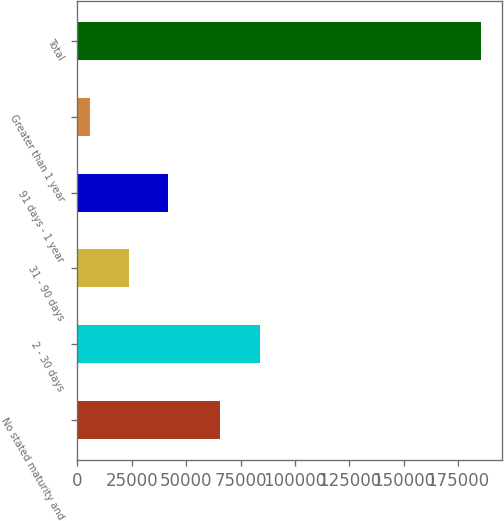Convert chart to OTSL. <chart><loc_0><loc_0><loc_500><loc_500><bar_chart><fcel>No stated maturity and<fcel>2 - 30 days<fcel>31 - 90 days<fcel>91 days - 1 year<fcel>Greater than 1 year<fcel>Total<nl><fcel>65764<fcel>83765.9<fcel>23731.9<fcel>41733.8<fcel>5730<fcel>185749<nl></chart> 